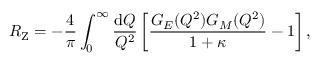<formula> <loc_0><loc_0><loc_500><loc_500>R _ { Z } = - \frac { 4 } { \pi } \int _ { 0 } ^ { \infty } \frac { d Q } { Q ^ { 2 } } \left [ \frac { G _ { E } ( Q ^ { 2 } ) G _ { M } ( Q ^ { 2 } ) } { 1 + \kappa } - 1 \right ] ,</formula> 